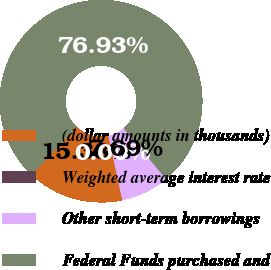Convert chart to OTSL. <chart><loc_0><loc_0><loc_500><loc_500><pie_chart><fcel>(dollar amounts in thousands)<fcel>Weighted average interest rate<fcel>Other short-term borrowings<fcel>Federal Funds purchased and<nl><fcel>15.38%<fcel>0.0%<fcel>7.69%<fcel>76.92%<nl></chart> 